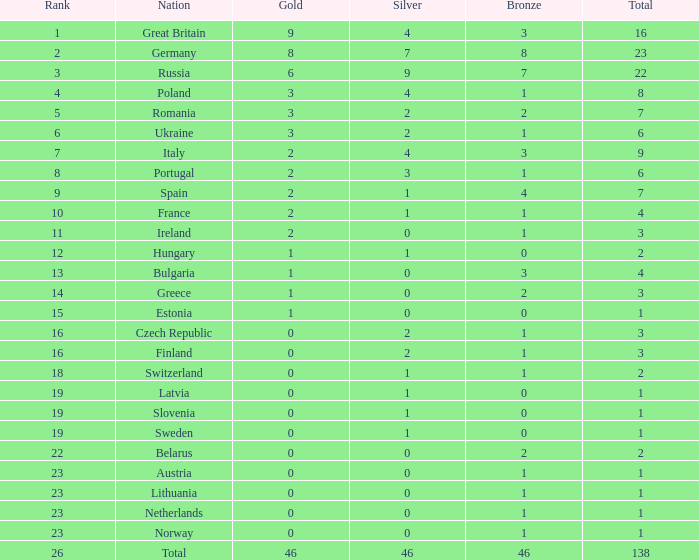What is the average rank when the bronze is larger than 1, and silver is less than 0? None. 